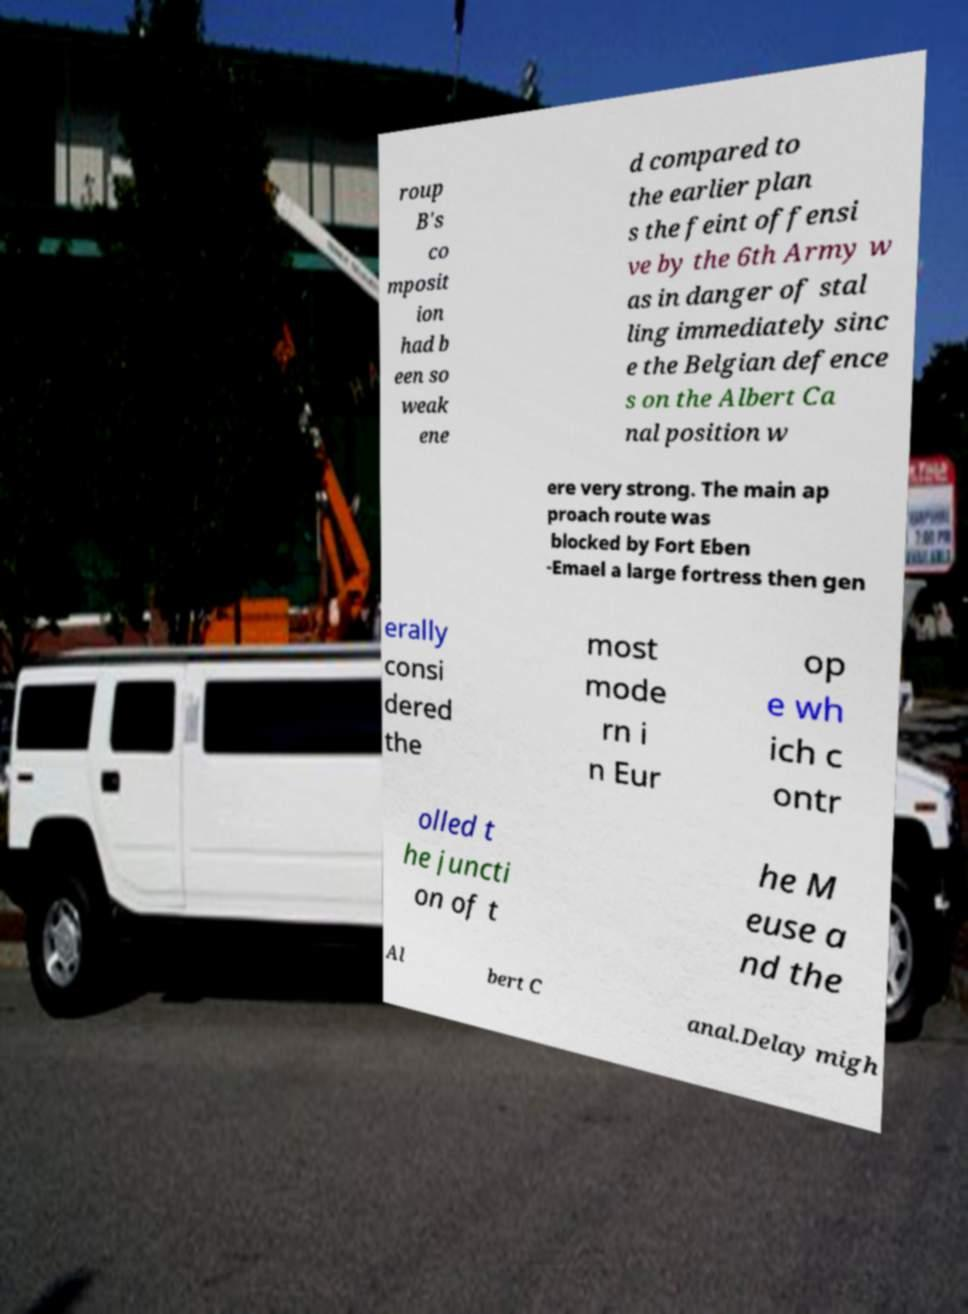For documentation purposes, I need the text within this image transcribed. Could you provide that? roup B's co mposit ion had b een so weak ene d compared to the earlier plan s the feint offensi ve by the 6th Army w as in danger of stal ling immediately sinc e the Belgian defence s on the Albert Ca nal position w ere very strong. The main ap proach route was blocked by Fort Eben -Emael a large fortress then gen erally consi dered the most mode rn i n Eur op e wh ich c ontr olled t he juncti on of t he M euse a nd the Al bert C anal.Delay migh 